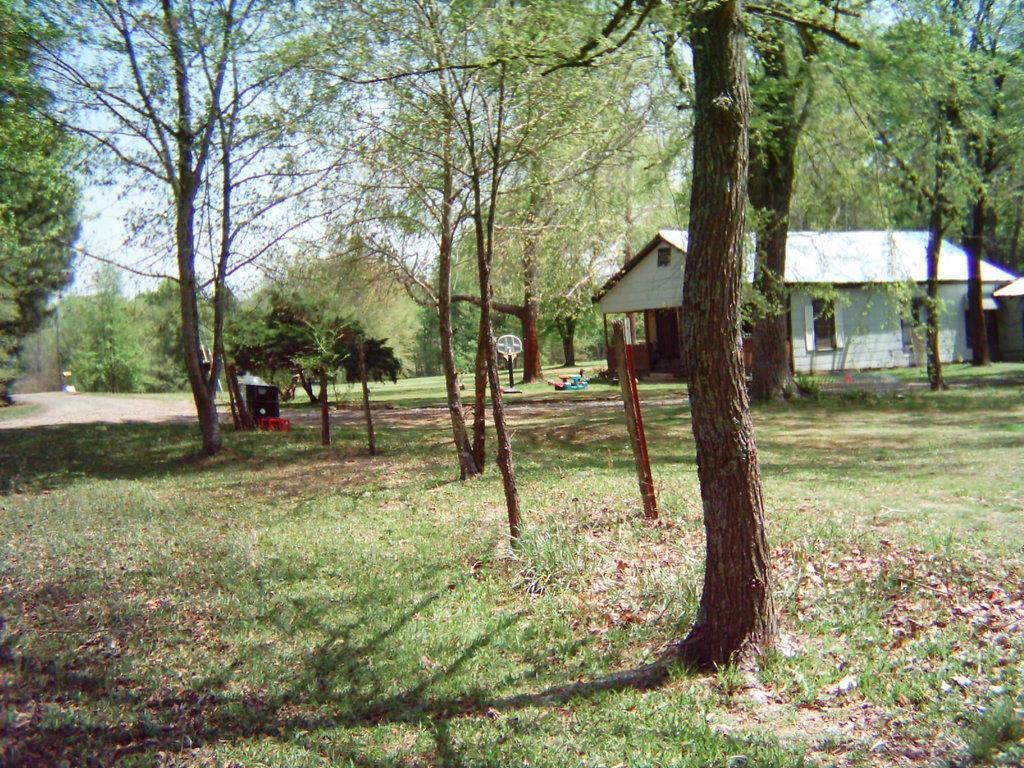In one or two sentences, can you explain what this image depicts? In this image there is a building on the grass ground around that there are so many trees and other objects. 